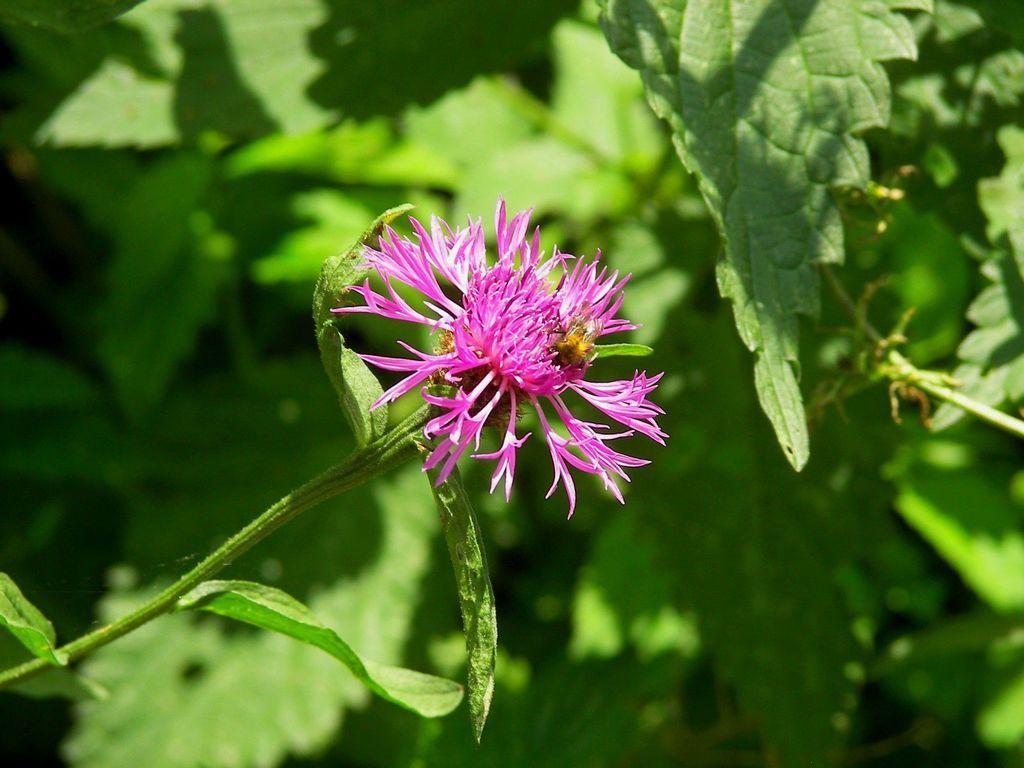How would you summarize this image in a sentence or two? In the image we can see a flower, pink in color. These are the leaves. 